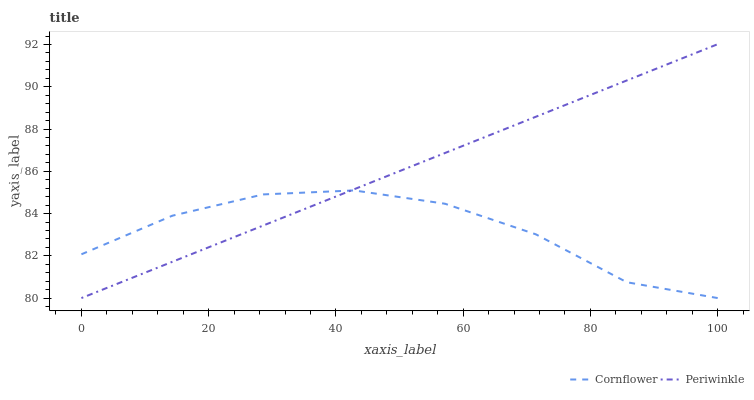Does Periwinkle have the minimum area under the curve?
Answer yes or no. No. Is Periwinkle the roughest?
Answer yes or no. No. 